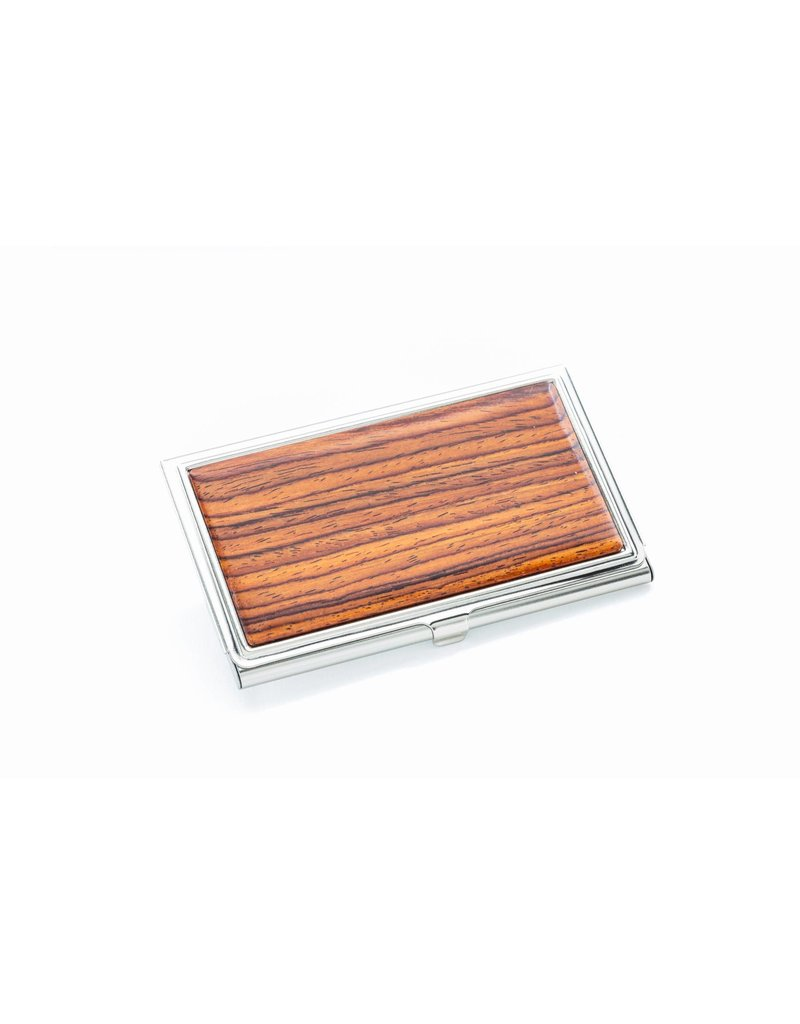What type of wood might the wooden panel on the case be made from, based on the grain pattern and color? Based on the image we have, the wooden panel on this sleek case presents a fine, even grain pattern and a warm, reddish-brown tone, traits which are characteristic of woods like mahogany or cherry. Such woods are prized for their beauty and durability, often used in fine furniture and decorative woodworking. Mahogany, for example, has a straight, fine, and even grain, and is relatively free of voids and pockets, making it a smooth, appealing surface for cases and similar items. Cherry has a rich reddish hue that darkens with age and exposure to light, giving it a sought-after patina over time. These attributes make both woods excellent choices for high-quality cases. However, it is essential to consider that the appearance alone—without physical examination or information on the weight and texture—doesn't tell us definitively whether this is solid wood or a veneer over a different substrate, or even an artificial imitation designed to replicate these classic woods. This distinction could affect the item's value and desirability, reminding us that while looks can be a good initial guide, there's often more to the story. 